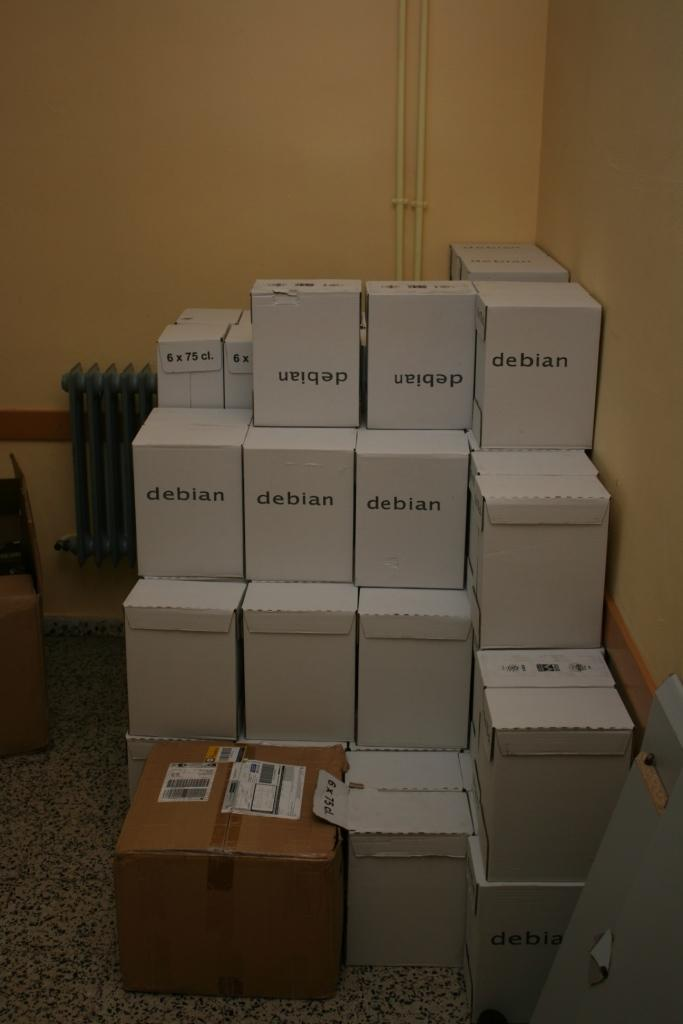Provide a one-sentence caption for the provided image. A room displaying numerous white boxes stacked labeled Debian. 